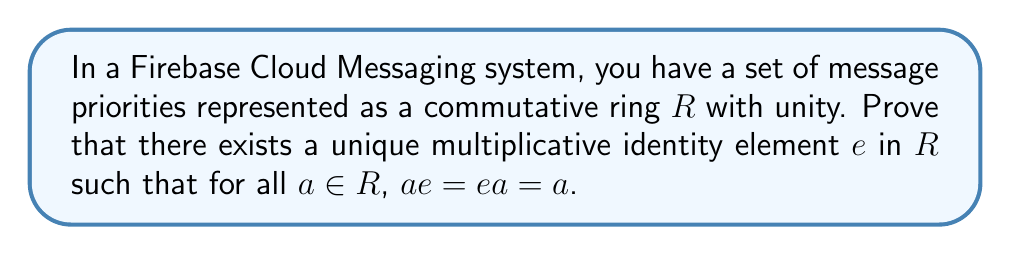Solve this math problem. Let's prove this step by step:

1) First, we know that $R$ is a commutative ring with unity. This means there exists an element $1 \in R$ such that for all $a \in R$, $1a = a1 = a$.

2) We need to prove that this element $1$ is unique. Let's assume there's another element $e \in R$ that also satisfies the property of multiplicative identity.

3) This means that for all $a \in R$, $ae = ea = a$.

4) Now, let's consider the product of $1$ and $e$:

   $$1e = e1 = e$$ (since $e$ is assumed to be an identity)
   $$1e = e1 = 1$$ (since $1$ is the known identity)

5) From these equations, we can conclude that $e = 1$.

6) This proves that the multiplicative identity is unique.

In the context of Firebase Cloud Messaging, this could represent that there's only one "normal" priority level that doesn't change the priority of a message when combined with other priorities.
Answer: The multiplicative identity $e$ in a commutative ring $R$ with unity exists and is unique. It is the element $1 \in R$ such that for all $a \in R$, $1a = a1 = a$. 